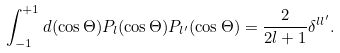Convert formula to latex. <formula><loc_0><loc_0><loc_500><loc_500>\int _ { - 1 } ^ { + 1 } d ( \cos \Theta ) P _ { l } ( \cos \Theta ) P _ { l ^ { \prime } } ( \cos \Theta ) = \frac { 2 } { 2 l + 1 } \delta ^ { l l ^ { \prime } } .</formula> 